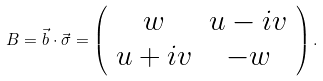<formula> <loc_0><loc_0><loc_500><loc_500>B = \vec { b } \cdot \vec { \sigma } = \left ( \begin{array} { c c } w & u - i v \\ u + i v & - w \end{array} \right ) .</formula> 